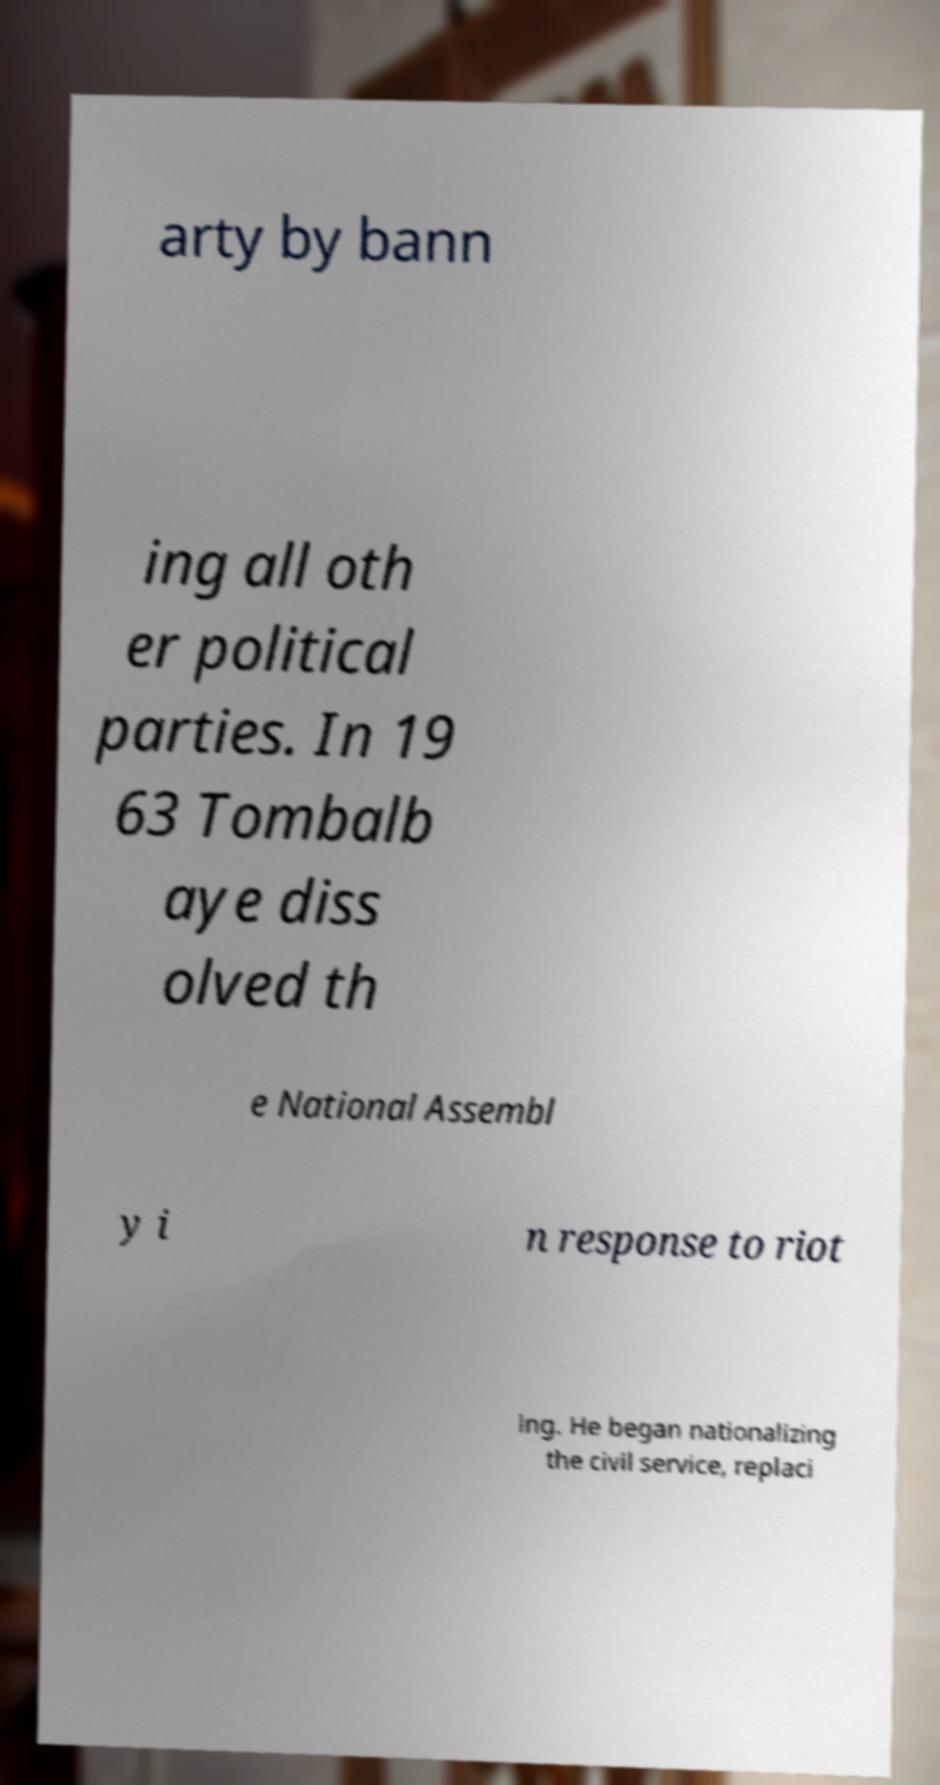I need the written content from this picture converted into text. Can you do that? arty by bann ing all oth er political parties. In 19 63 Tombalb aye diss olved th e National Assembl y i n response to riot ing. He began nationalizing the civil service, replaci 